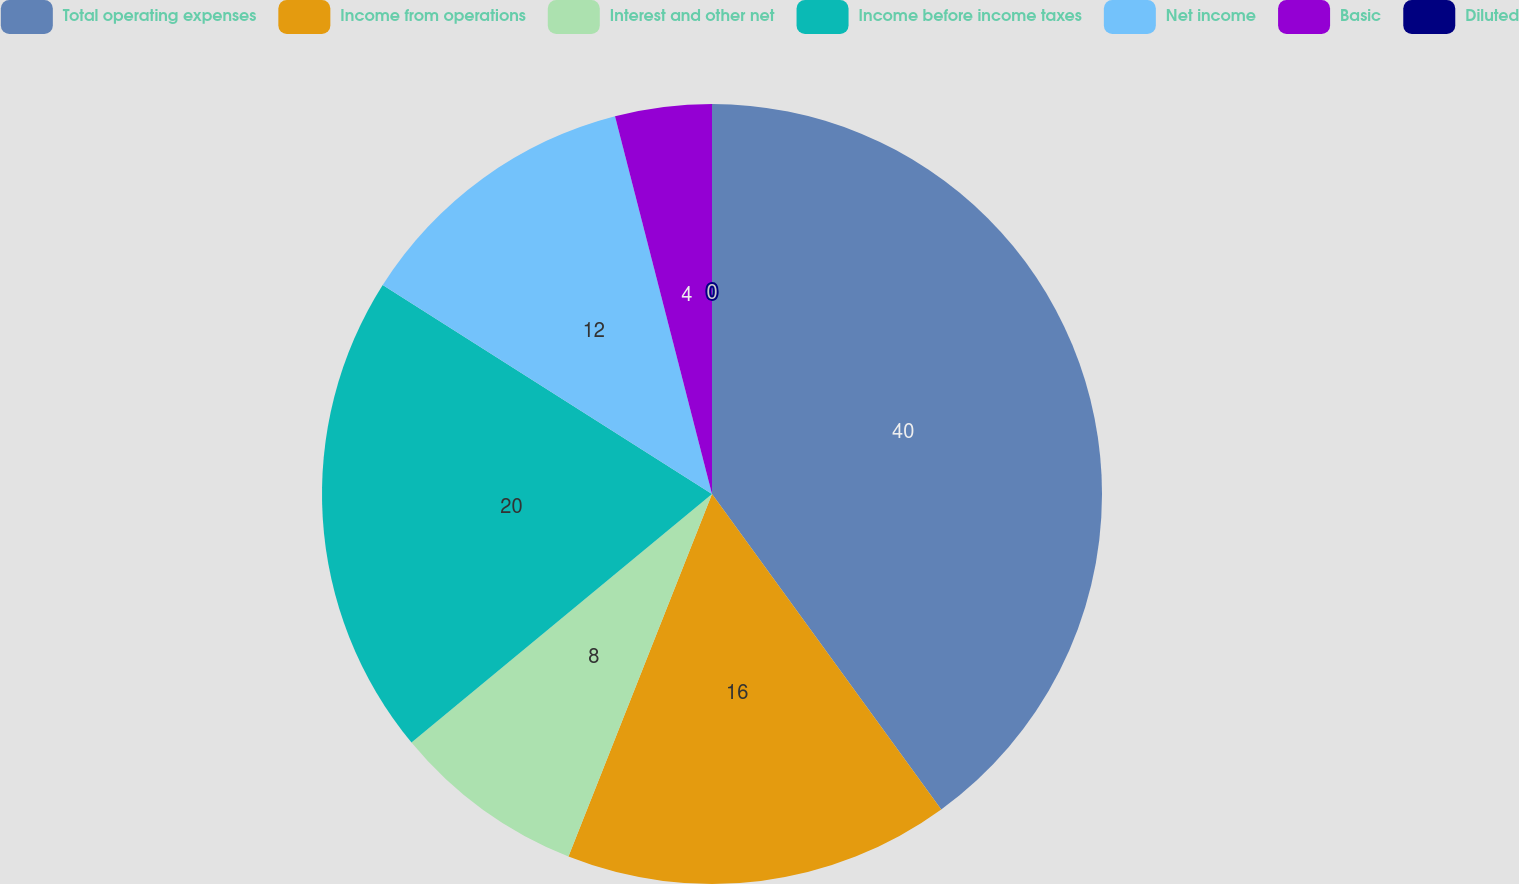Convert chart to OTSL. <chart><loc_0><loc_0><loc_500><loc_500><pie_chart><fcel>Total operating expenses<fcel>Income from operations<fcel>Interest and other net<fcel>Income before income taxes<fcel>Net income<fcel>Basic<fcel>Diluted<nl><fcel>40.0%<fcel>16.0%<fcel>8.0%<fcel>20.0%<fcel>12.0%<fcel>4.0%<fcel>0.0%<nl></chart> 